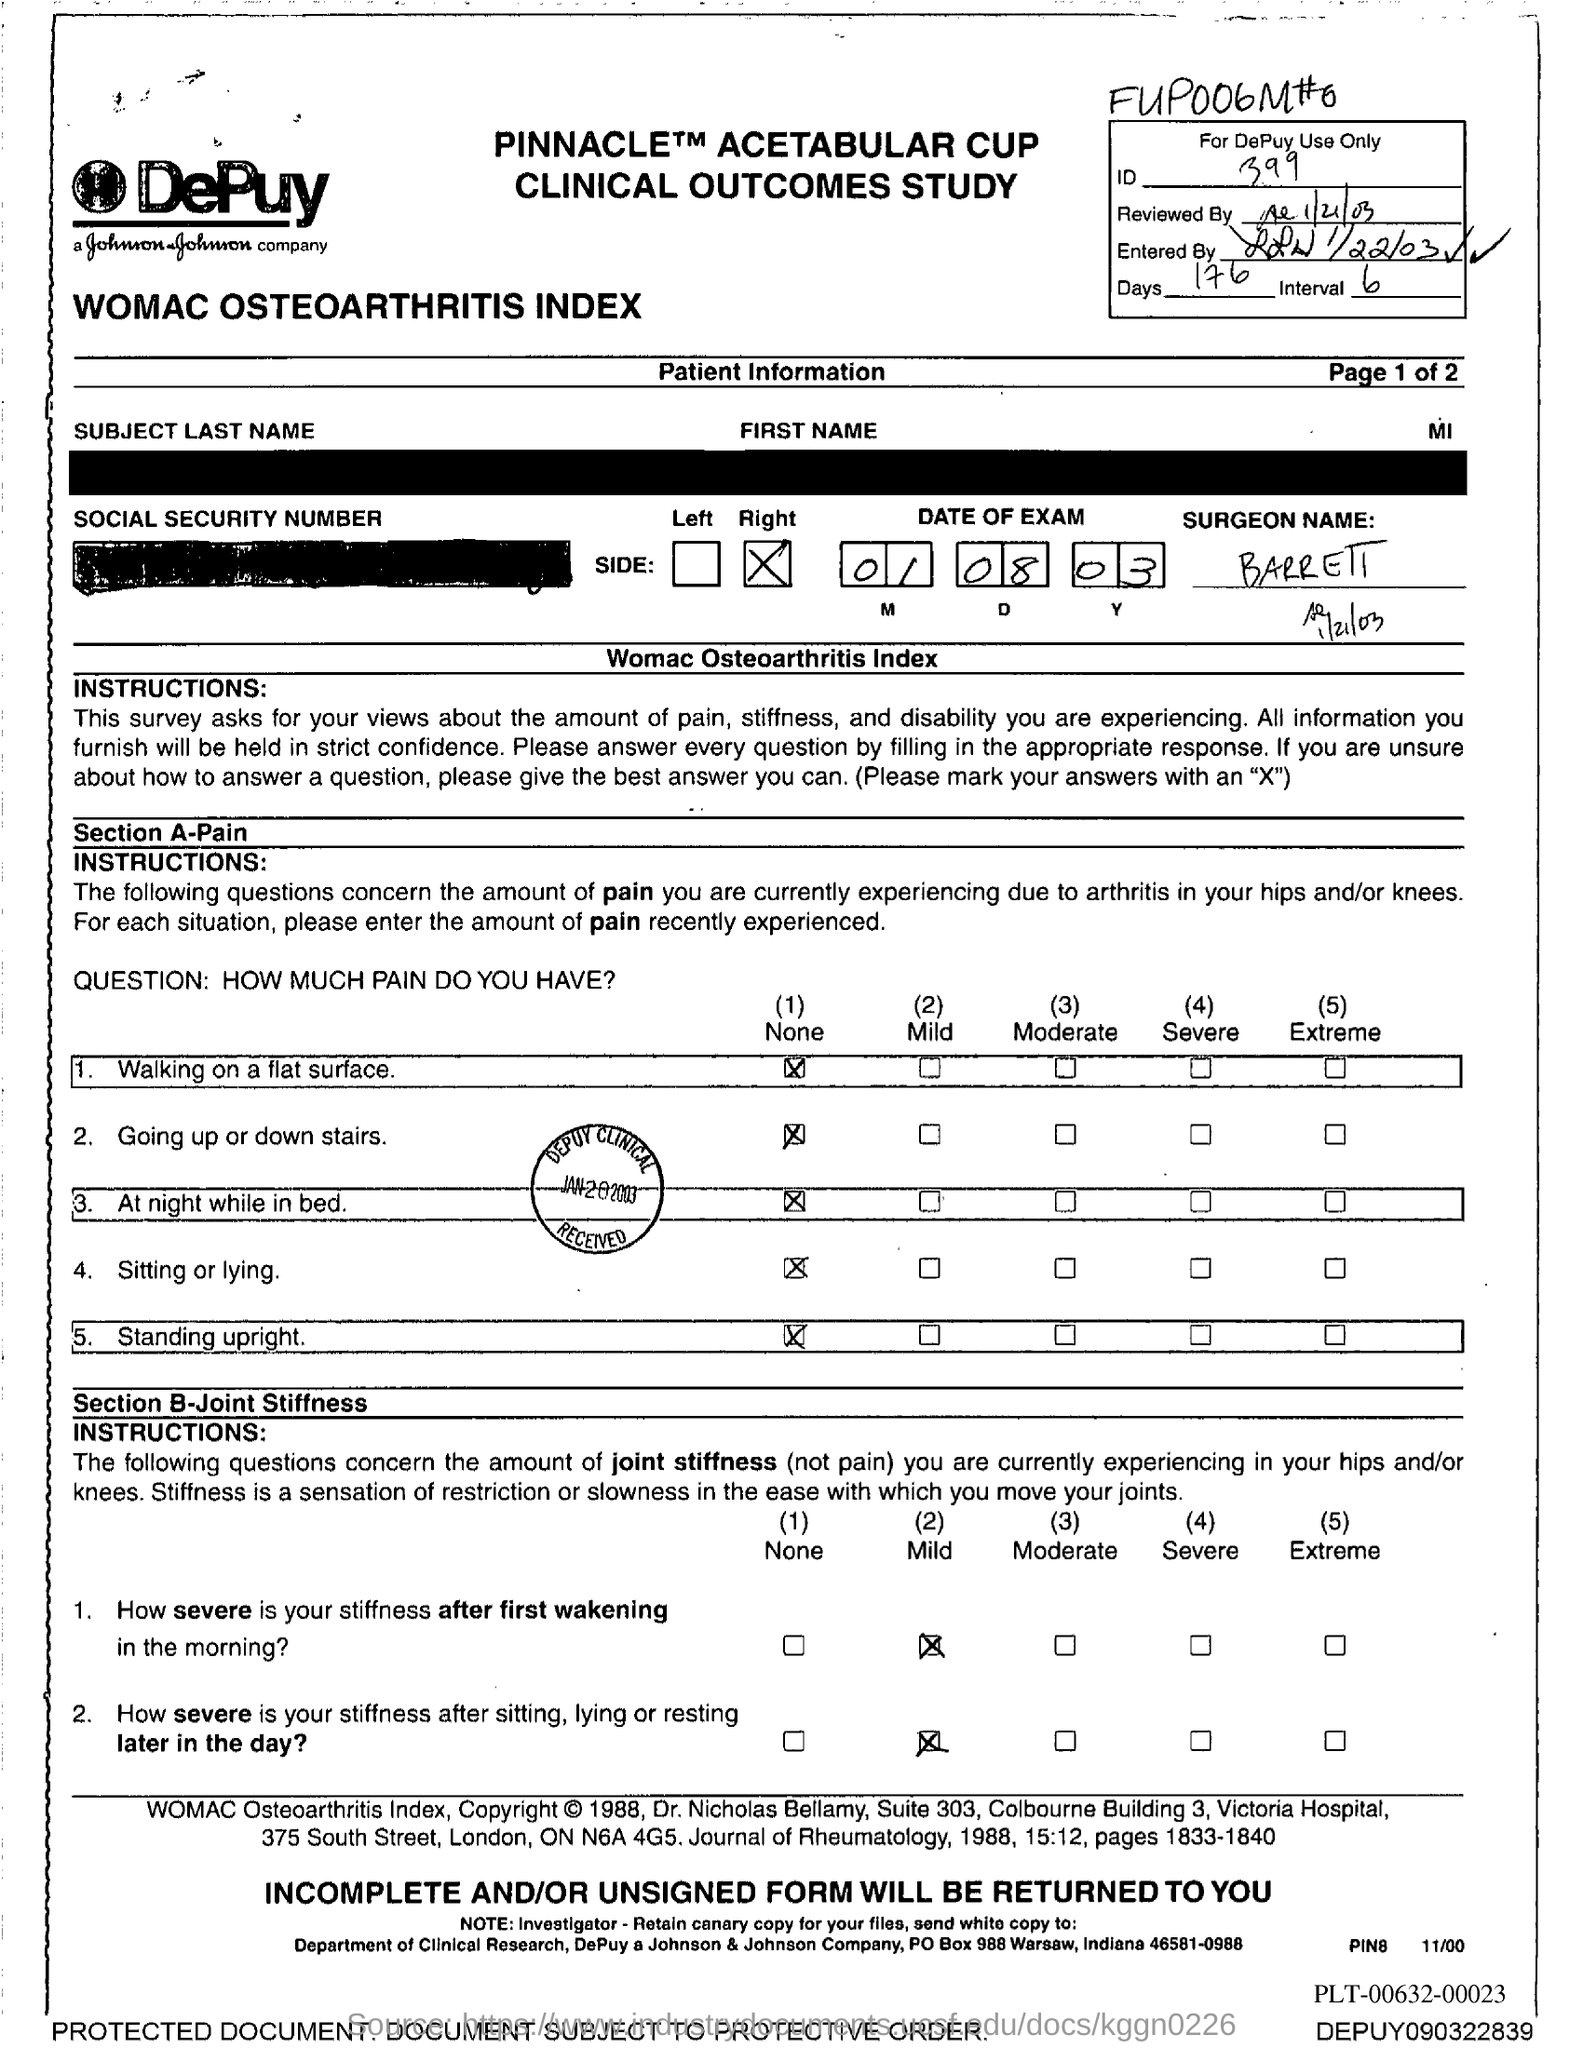Point out several critical features in this image. The date of the exam as mentioned in the document is August 1, 2003. The document provides 176 days. The document contains an ID number of 399. 